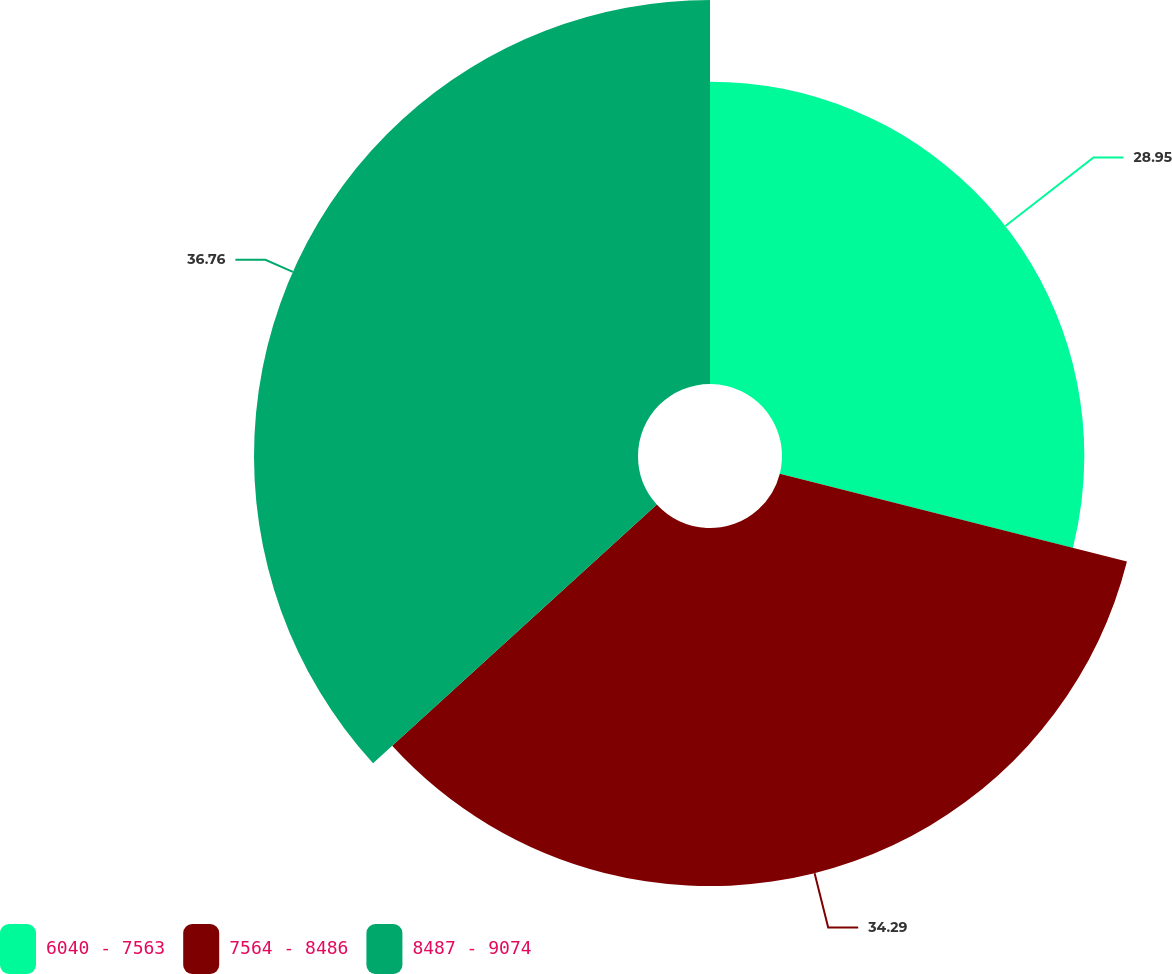Convert chart to OTSL. <chart><loc_0><loc_0><loc_500><loc_500><pie_chart><fcel>6040 - 7563<fcel>7564 - 8486<fcel>8487 - 9074<nl><fcel>28.95%<fcel>34.29%<fcel>36.77%<nl></chart> 